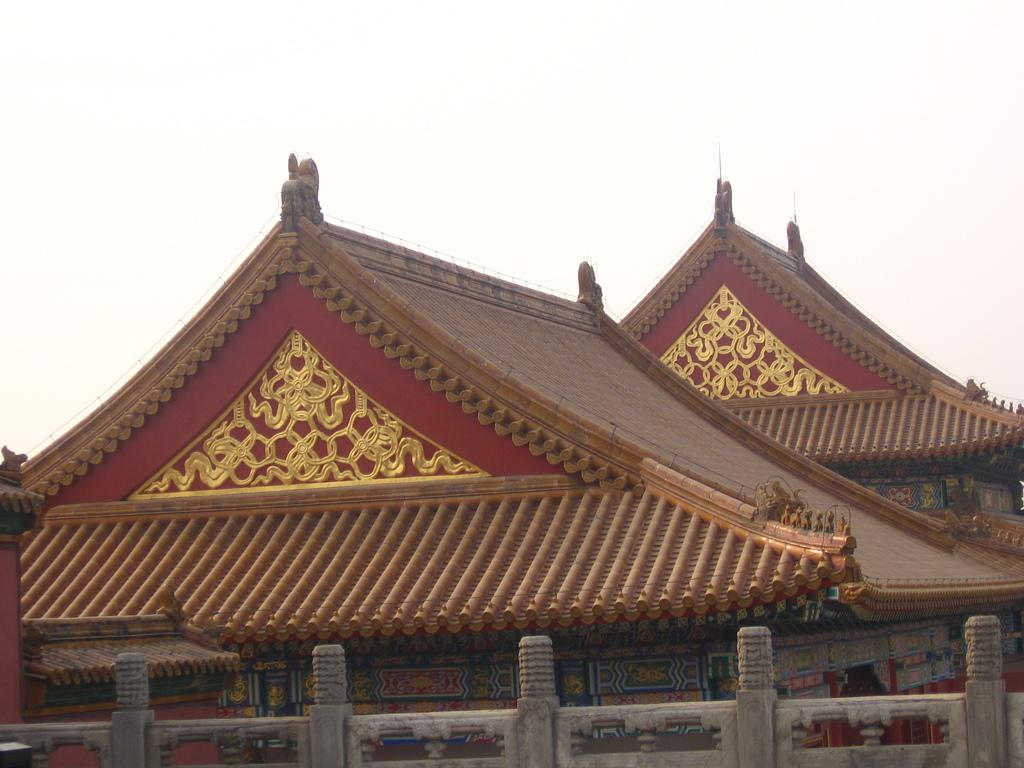What type of structures can be seen in the image? There are roofs of houses in the image. What part of the natural environment is visible in the image? The sky is visible in the background of the image. What type of plant is being carried by the passenger in the image? There is no passenger or plant present in the image; it only features roofs of houses and the sky. 